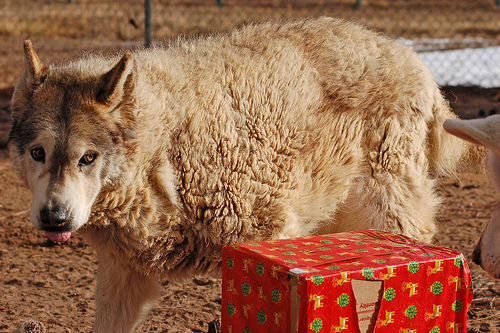<image>
Is there a wolf behind the box? Yes. From this viewpoint, the wolf is positioned behind the box, with the box partially or fully occluding the wolf. Where is the ground in relation to the present? Is it behind the present? No. The ground is not behind the present. From this viewpoint, the ground appears to be positioned elsewhere in the scene. 